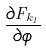<formula> <loc_0><loc_0><loc_500><loc_500>\frac { \partial F _ { k _ { 1 } } } { \partial \phi }</formula> 